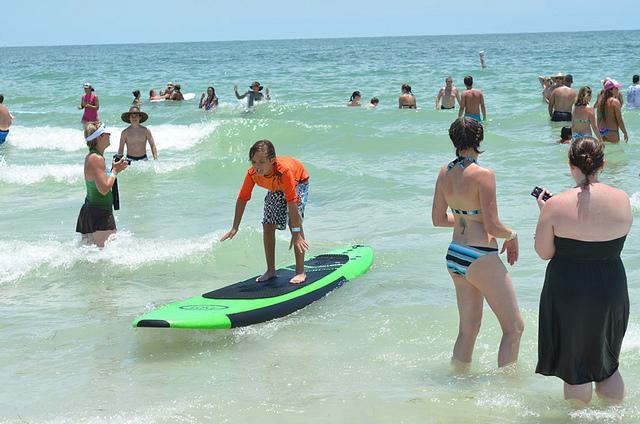Are these people in a swimming pool?
Keep it brief. No. Which woman has worn a black dress?
Keep it brief. Right. How many surfboards are there?
Short answer required. 1. 